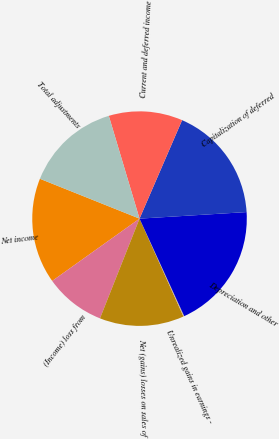Convert chart. <chart><loc_0><loc_0><loc_500><loc_500><pie_chart><fcel>Net income<fcel>(Income) loss from<fcel>Net (gains) losses on sales of<fcel>Unrealized gains in earnings -<fcel>Depreciation and other<fcel>Capitalization of deferred<fcel>Current and deferred income<fcel>Total adjustments<nl><fcel>15.92%<fcel>9.13%<fcel>12.72%<fcel>0.13%<fcel>19.13%<fcel>17.53%<fcel>11.12%<fcel>14.32%<nl></chart> 